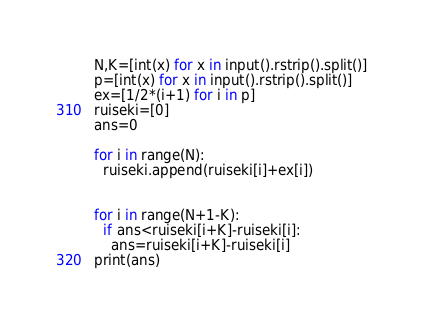Convert code to text. <code><loc_0><loc_0><loc_500><loc_500><_Python_>N,K=[int(x) for x in input().rstrip().split()]
p=[int(x) for x in input().rstrip().split()]
ex=[1/2*(i+1) for i in p]
ruiseki=[0]
ans=0

for i in range(N):
  ruiseki.append(ruiseki[i]+ex[i])


for i in range(N+1-K):
  if ans<ruiseki[i+K]-ruiseki[i]:
    ans=ruiseki[i+K]-ruiseki[i]
print(ans)
</code> 